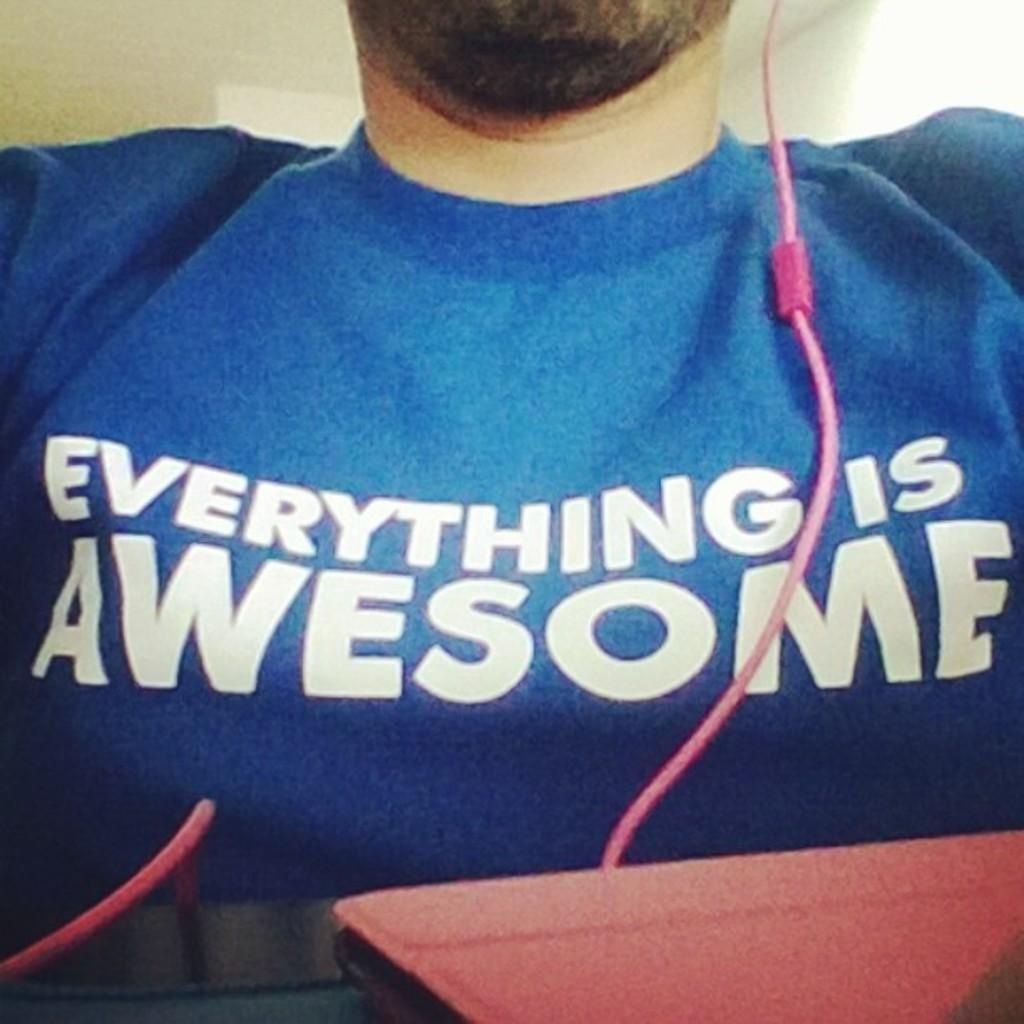<image>
Create a compact narrative representing the image presented. a shirt that says everything is awesome on it 